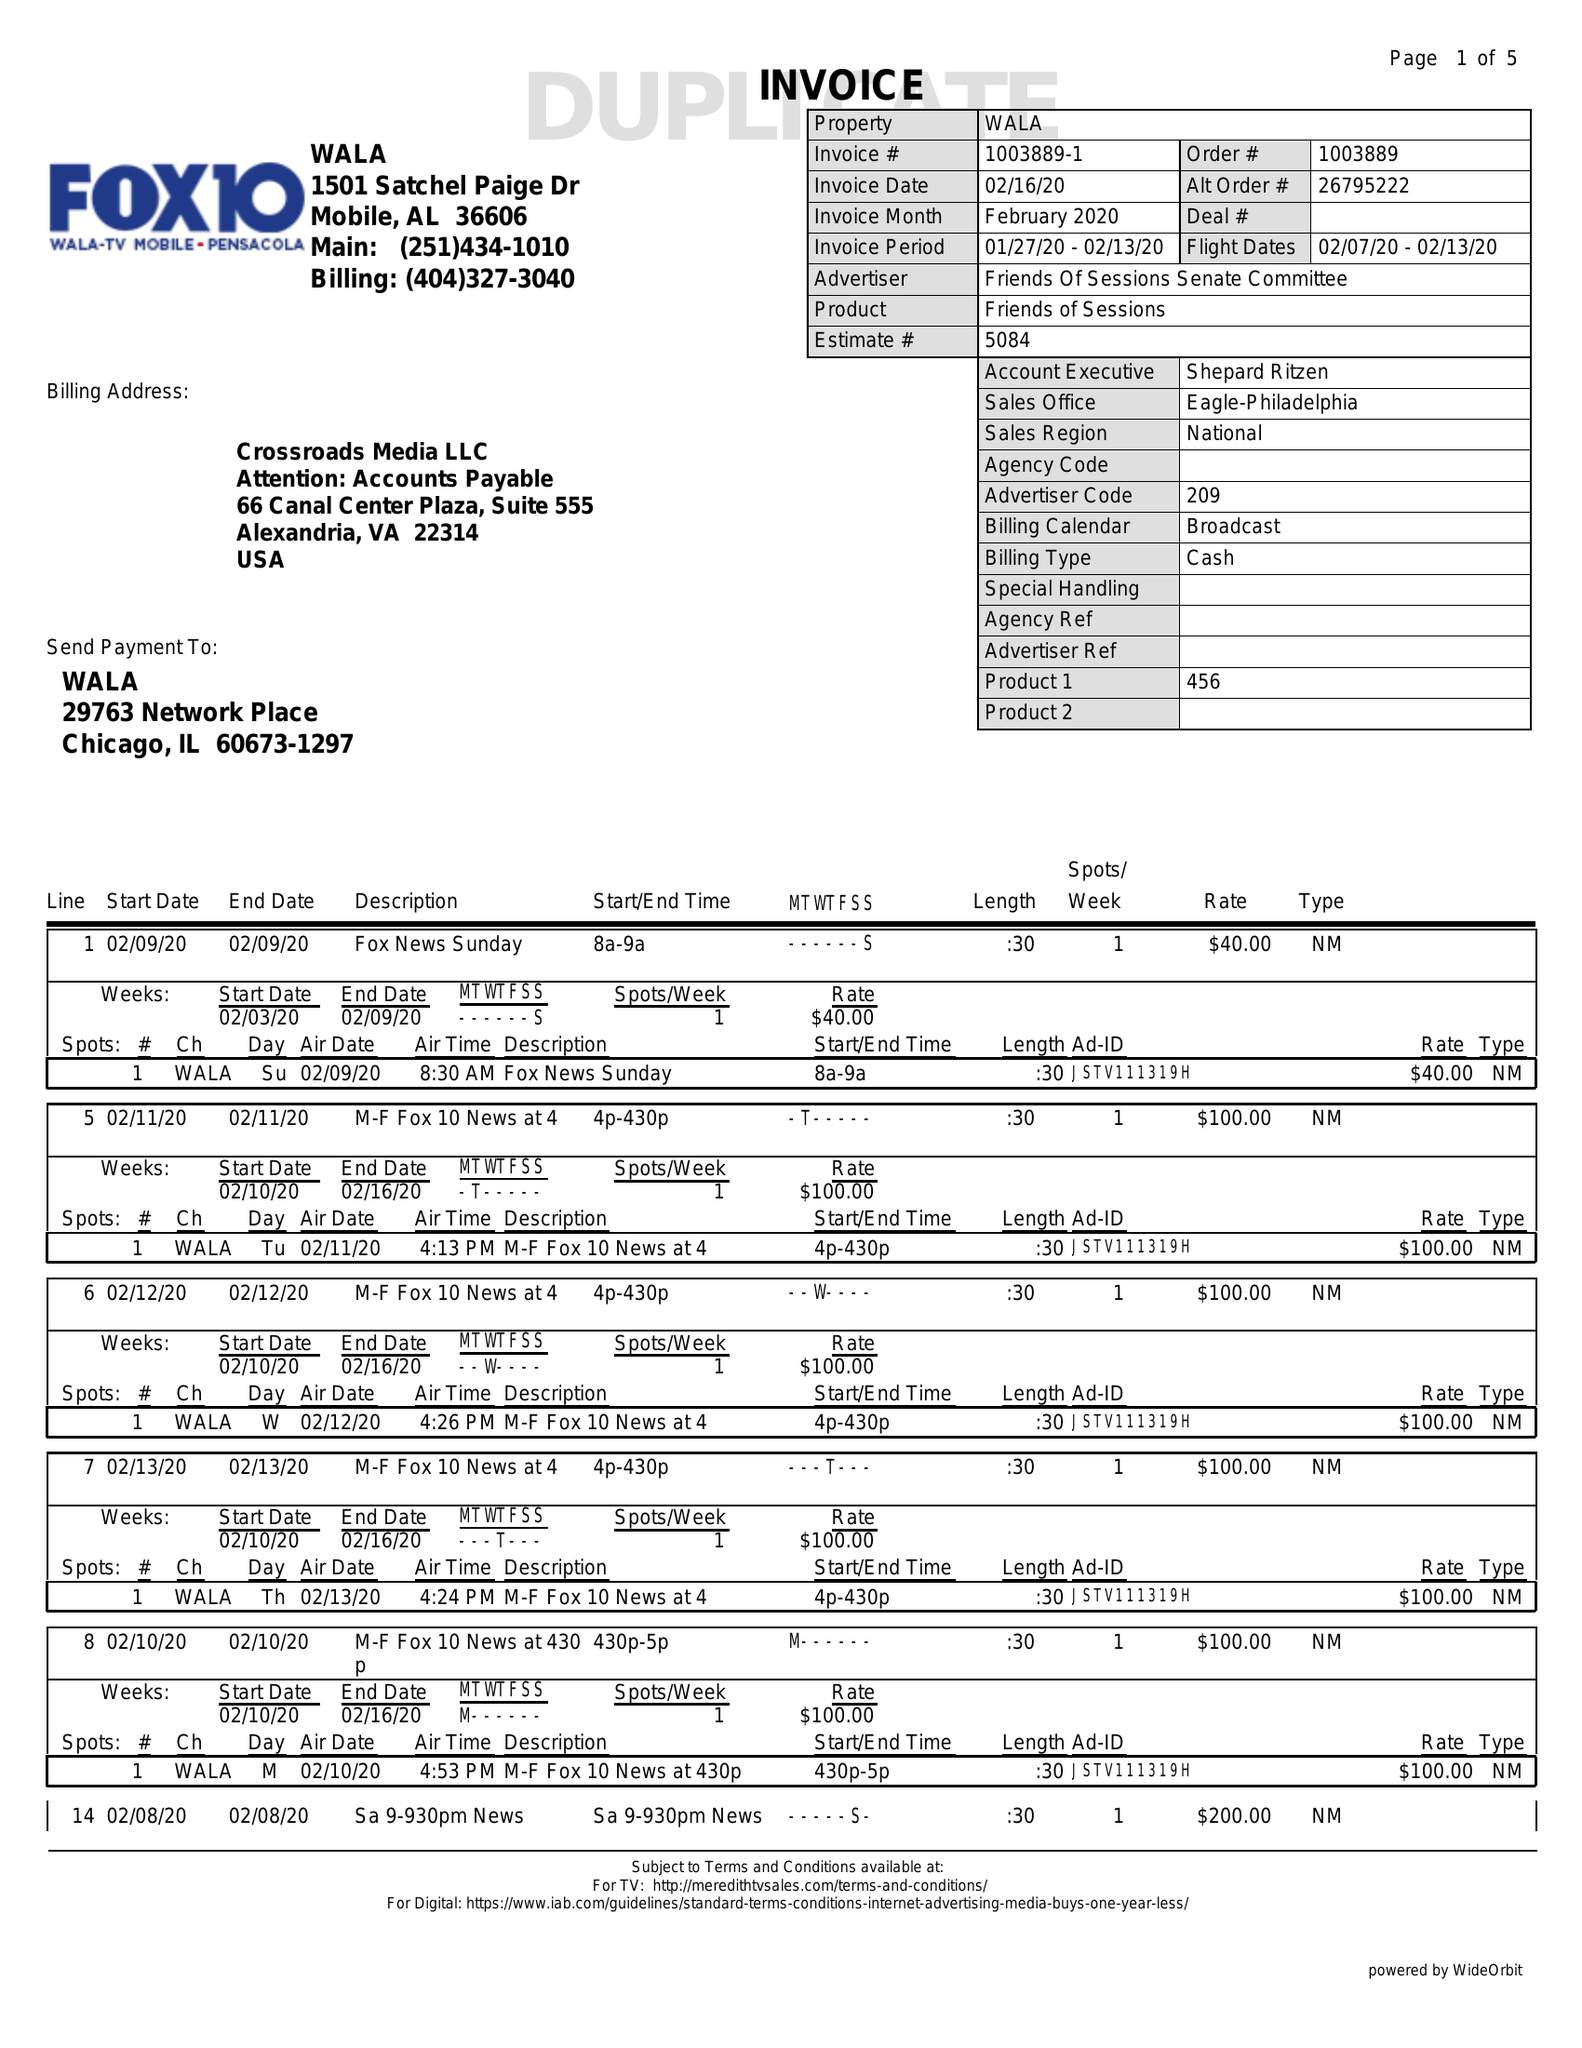What is the value for the advertiser?
Answer the question using a single word or phrase. FRIENDS OF SESSIONS SENATE COMMITTEE 